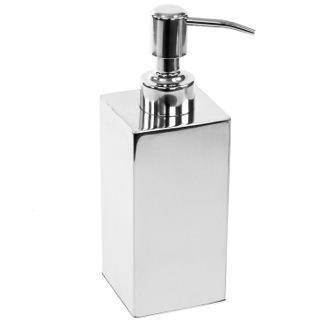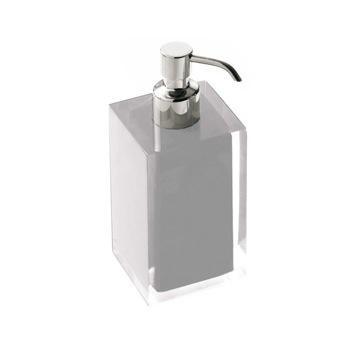The first image is the image on the left, the second image is the image on the right. Given the left and right images, does the statement "The dispenser on the left is rectangular in shape." hold true? Answer yes or no. Yes. 